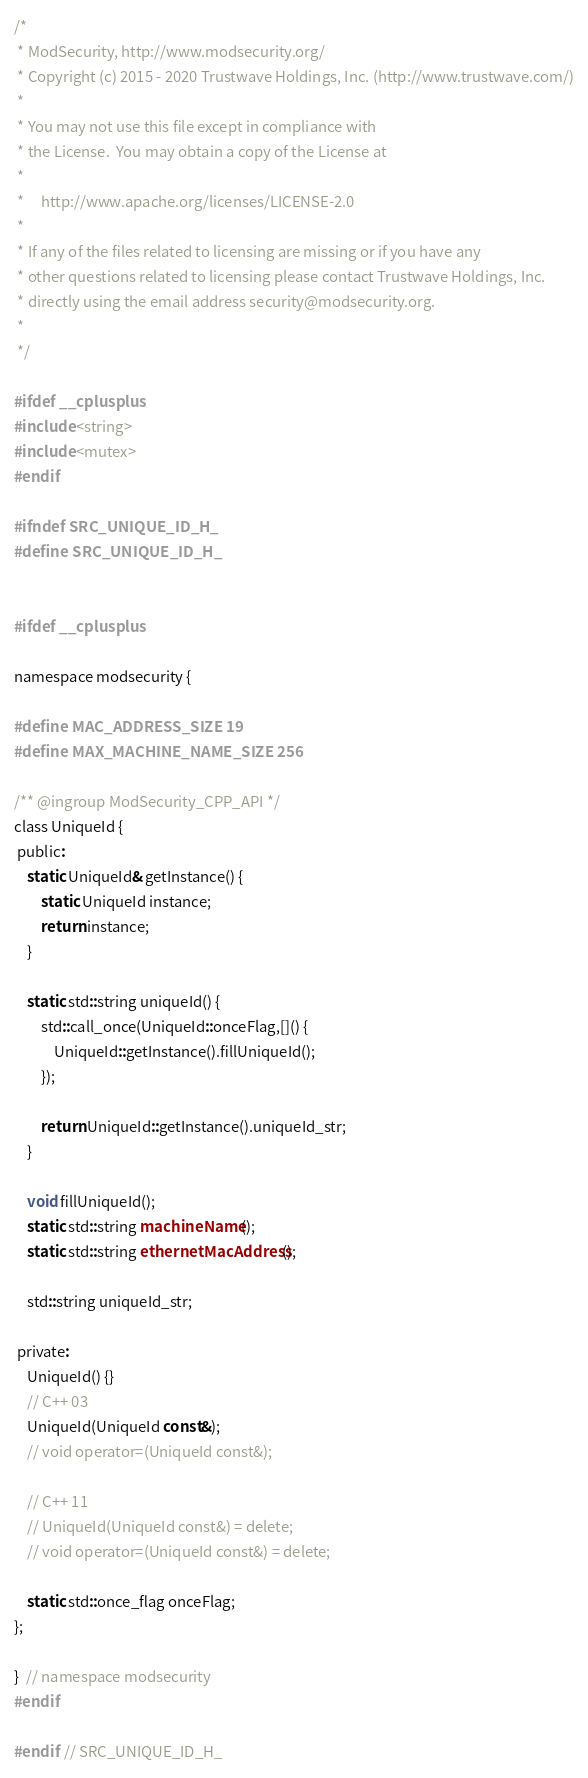Convert code to text. <code><loc_0><loc_0><loc_500><loc_500><_C_>/*
 * ModSecurity, http://www.modsecurity.org/
 * Copyright (c) 2015 - 2020 Trustwave Holdings, Inc. (http://www.trustwave.com/)
 *
 * You may not use this file except in compliance with
 * the License.  You may obtain a copy of the License at
 *
 *     http://www.apache.org/licenses/LICENSE-2.0
 *
 * If any of the files related to licensing are missing or if you have any
 * other questions related to licensing please contact Trustwave Holdings, Inc.
 * directly using the email address security@modsecurity.org.
 *
 */

#ifdef __cplusplus
#include <string>
#include <mutex>
#endif

#ifndef SRC_UNIQUE_ID_H_
#define SRC_UNIQUE_ID_H_


#ifdef __cplusplus

namespace modsecurity {

#define MAC_ADDRESS_SIZE 19
#define MAX_MACHINE_NAME_SIZE 256

/** @ingroup ModSecurity_CPP_API */
class UniqueId {
 public:
    static UniqueId& getInstance() {
        static UniqueId instance;
        return instance;
    }

    static std::string uniqueId() {
        std::call_once(UniqueId::onceFlag,[]() {
            UniqueId::getInstance().fillUniqueId();
        });

        return UniqueId::getInstance().uniqueId_str;
    }

    void fillUniqueId();
    static std::string machineName();
    static std::string ethernetMacAddress();

    std::string uniqueId_str;

 private:
    UniqueId() {}
    // C++ 03
    UniqueId(UniqueId const&);
    // void operator=(UniqueId const&);

    // C++ 11
    // UniqueId(UniqueId const&) = delete;
    // void operator=(UniqueId const&) = delete;

    static std::once_flag onceFlag;
};

}  // namespace modsecurity
#endif

#endif  // SRC_UNIQUE_ID_H_
</code> 